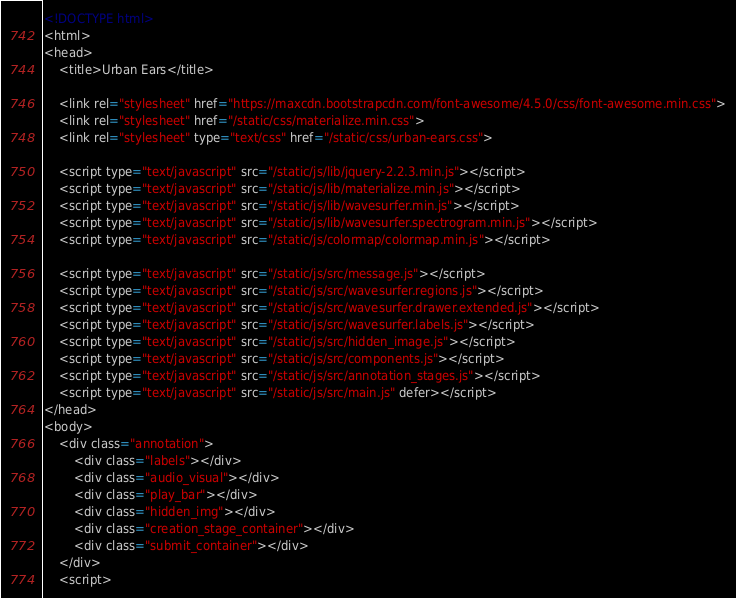Convert code to text. <code><loc_0><loc_0><loc_500><loc_500><_HTML_><!DOCTYPE html>
<html>
<head>
    <title>Urban Ears</title>

    <link rel="stylesheet" href="https://maxcdn.bootstrapcdn.com/font-awesome/4.5.0/css/font-awesome.min.css">
    <link rel="stylesheet" href="/static/css/materialize.min.css">
    <link rel="stylesheet" type="text/css" href="/static/css/urban-ears.css">

    <script type="text/javascript" src="/static/js/lib/jquery-2.2.3.min.js"></script>
    <script type="text/javascript" src="/static/js/lib/materialize.min.js"></script>
    <script type="text/javascript" src="/static/js/lib/wavesurfer.min.js"></script>
    <script type="text/javascript" src="/static/js/lib/wavesurfer.spectrogram.min.js"></script>
    <script type="text/javascript" src="/static/js/colormap/colormap.min.js"></script>

    <script type="text/javascript" src="/static/js/src/message.js"></script>
    <script type="text/javascript" src="/static/js/src/wavesurfer.regions.js"></script>
    <script type="text/javascript" src="/static/js/src/wavesurfer.drawer.extended.js"></script>
    <script type="text/javascript" src="/static/js/src/wavesurfer.labels.js"></script>
    <script type="text/javascript" src="/static/js/src/hidden_image.js"></script>
    <script type="text/javascript" src="/static/js/src/components.js"></script>
    <script type="text/javascript" src="/static/js/src/annotation_stages.js"></script>
    <script type="text/javascript" src="/static/js/src/main.js" defer></script>
</head>
<body>
    <div class="annotation">
        <div class="labels"></div>
        <div class="audio_visual"></div>
        <div class="play_bar"></div>
        <div class="hidden_img"></div>
        <div class="creation_stage_container"></div>
        <div class="submit_container"></div>
    </div> 
    <script></code> 